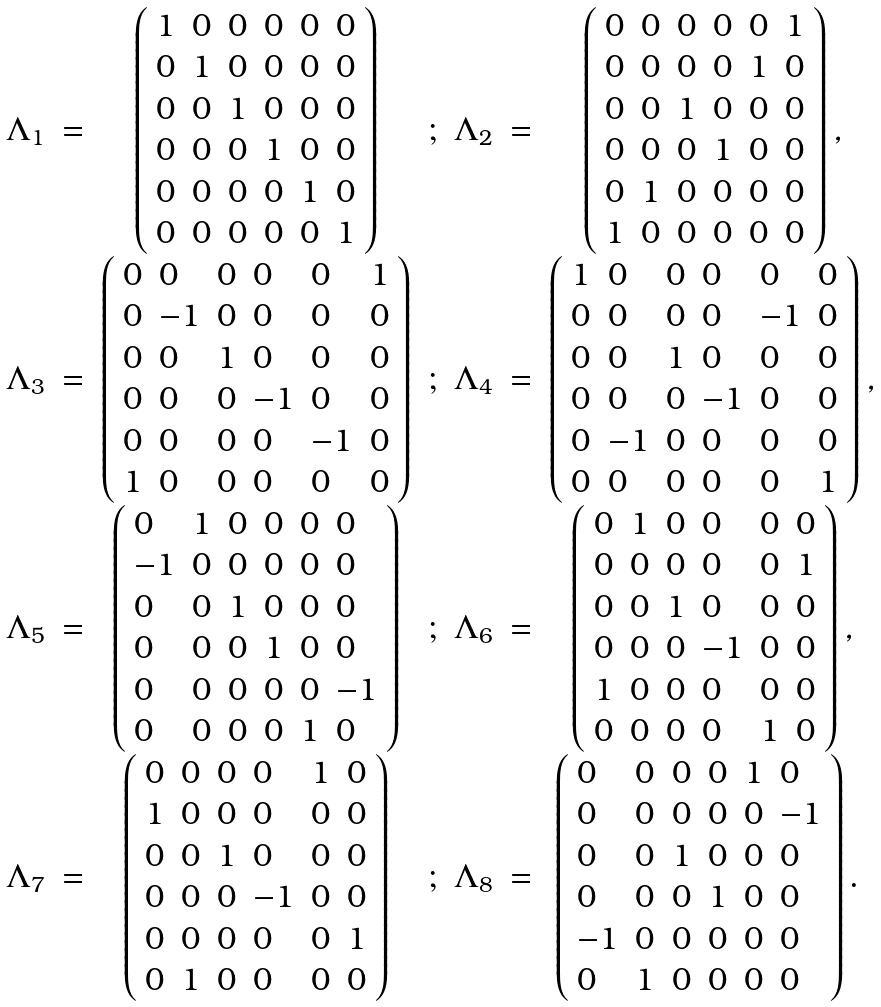<formula> <loc_0><loc_0><loc_500><loc_500>\begin{array} { c c c c c c c } \Lambda _ { 1 } & = & \left ( \begin{array} { l l l l l l } 1 & 0 & 0 & 0 & 0 & 0 \\ 0 & 1 & 0 & 0 & 0 & 0 \\ 0 & 0 & 1 & 0 & 0 & 0 \\ 0 & 0 & 0 & 1 & 0 & 0 \\ 0 & 0 & 0 & 0 & 1 & 0 \\ 0 & 0 & 0 & 0 & 0 & 1 \end{array} \right ) & ; & \Lambda _ { 2 } & = & \left ( \begin{array} { l l l l l l } 0 & 0 & 0 & 0 & 0 & 1 \\ 0 & 0 & 0 & 0 & 1 & 0 \\ 0 & 0 & 1 & 0 & 0 & 0 \\ 0 & 0 & 0 & 1 & 0 & 0 \\ 0 & 1 & 0 & 0 & 0 & 0 \\ 1 & 0 & 0 & 0 & 0 & 0 \end{array} \right ) , \\ \Lambda _ { 3 } & = & \left ( \begin{array} { l l l l l l } 0 & 0 & 0 & 0 & 0 & 1 \\ 0 & - 1 & 0 & 0 & 0 & 0 \\ 0 & 0 & 1 & 0 & 0 & 0 \\ 0 & 0 & 0 & - 1 & 0 & 0 \\ 0 & 0 & 0 & 0 & - 1 & 0 \\ 1 & 0 & 0 & 0 & 0 & 0 \end{array} \right ) & ; & \Lambda _ { 4 } & = & \left ( \begin{array} { l l l l l l } 1 & 0 & 0 & 0 & 0 & 0 \\ 0 & 0 & 0 & 0 & - 1 & 0 \\ 0 & 0 & 1 & 0 & 0 & 0 \\ 0 & 0 & 0 & - 1 & 0 & 0 \\ 0 & - 1 & 0 & 0 & 0 & 0 \\ 0 & 0 & 0 & 0 & 0 & 1 \end{array} \right ) , \\ \Lambda _ { 5 } & = & \left ( \begin{array} { l l l l l l } 0 & 1 & 0 & 0 & 0 & 0 \\ - 1 & 0 & 0 & 0 & 0 & 0 \\ 0 & 0 & 1 & 0 & 0 & 0 \\ 0 & 0 & 0 & 1 & 0 & 0 \\ 0 & 0 & 0 & 0 & 0 & - 1 \\ 0 & 0 & 0 & 0 & 1 & 0 \end{array} \right ) & ; & \Lambda _ { 6 } & = & \left ( \begin{array} { l l l l l l } 0 & 1 & 0 & 0 & 0 & 0 \\ 0 & 0 & 0 & 0 & 0 & 1 \\ 0 & 0 & 1 & 0 & 0 & 0 \\ 0 & 0 & 0 & - 1 & 0 & 0 \\ 1 & 0 & 0 & 0 & 0 & 0 \\ 0 & 0 & 0 & 0 & 1 & 0 \end{array} \right ) , \\ \Lambda _ { 7 } & = & \left ( \begin{array} { l l l l l l } 0 & 0 & 0 & 0 & 1 & 0 \\ 1 & 0 & 0 & 0 & 0 & 0 \\ 0 & 0 & 1 & 0 & 0 & 0 \\ 0 & 0 & 0 & - 1 & 0 & 0 \\ 0 & 0 & 0 & 0 & 0 & 1 \\ 0 & 1 & 0 & 0 & 0 & 0 \end{array} \right ) & ; & \Lambda _ { 8 } & = & \left ( \begin{array} { l l l l l l } 0 & 0 & 0 & 0 & 1 & 0 \\ 0 & 0 & 0 & 0 & 0 & - 1 \\ 0 & 0 & 1 & 0 & 0 & 0 \\ 0 & 0 & 0 & 1 & 0 & 0 \\ - 1 & 0 & 0 & 0 & 0 & 0 \\ 0 & 1 & 0 & 0 & 0 & 0 \end{array} \right ) . \ \end{array}</formula> 